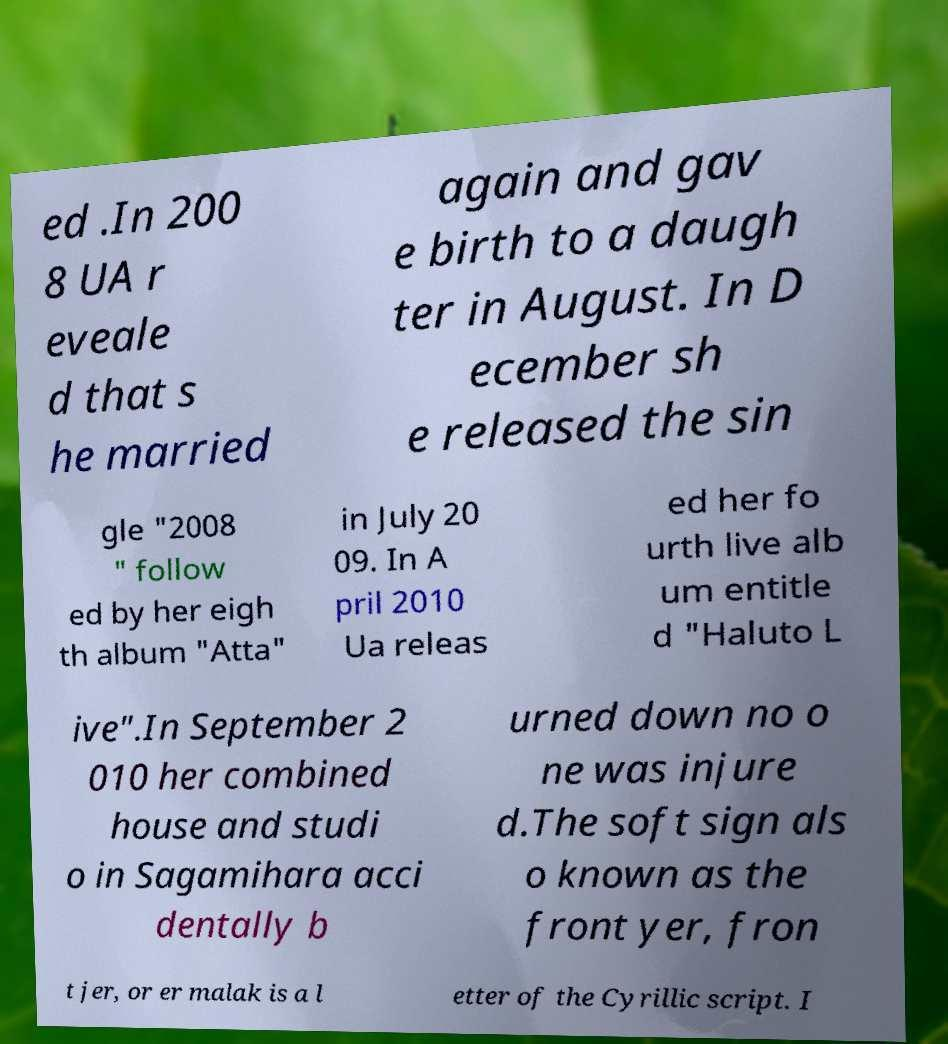Can you accurately transcribe the text from the provided image for me? ed .In 200 8 UA r eveale d that s he married again and gav e birth to a daugh ter in August. In D ecember sh e released the sin gle "2008 " follow ed by her eigh th album "Atta" in July 20 09. In A pril 2010 Ua releas ed her fo urth live alb um entitle d "Haluto L ive".In September 2 010 her combined house and studi o in Sagamihara acci dentally b urned down no o ne was injure d.The soft sign als o known as the front yer, fron t jer, or er malak is a l etter of the Cyrillic script. I 